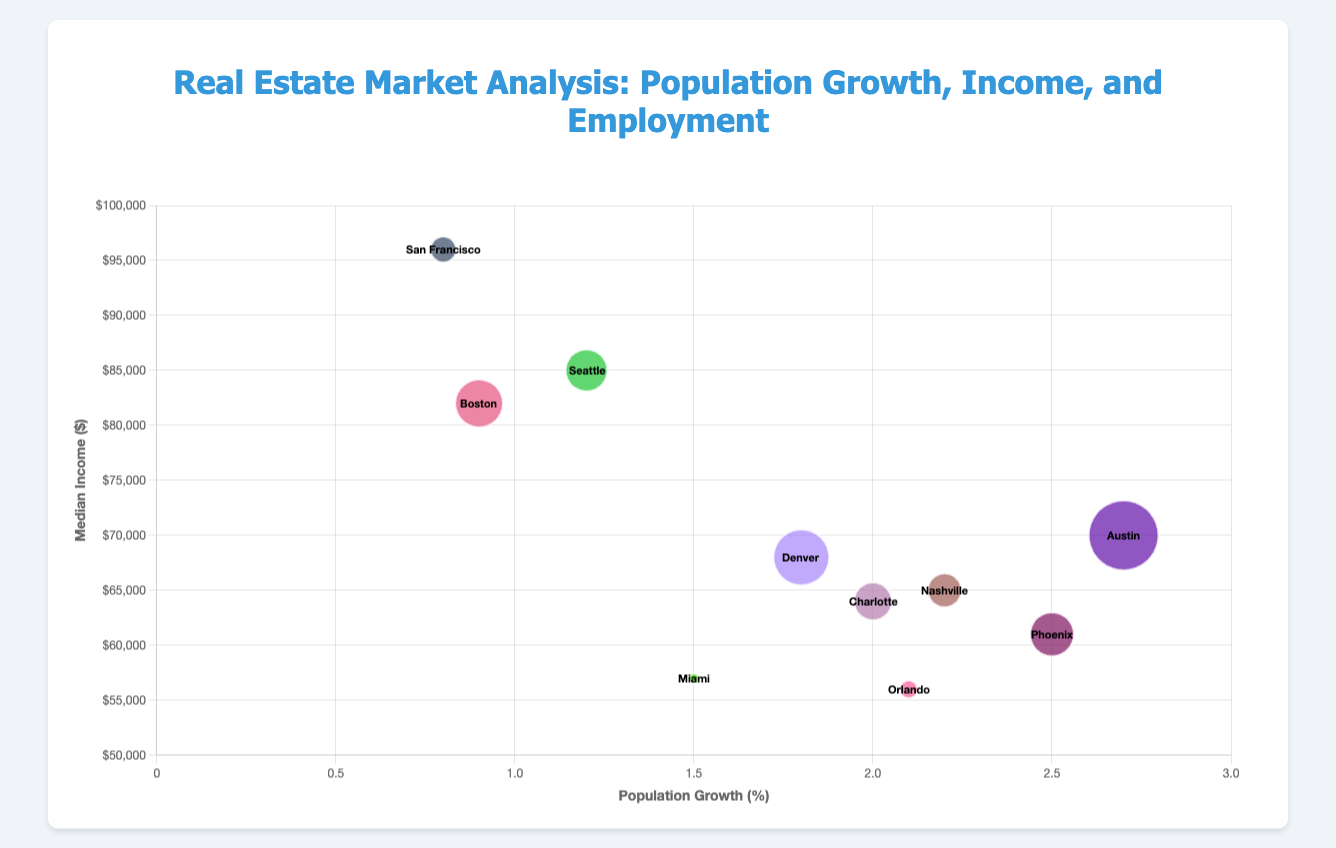What's the title of the figure? The title of the figure is displayed at the top and reads "Real Estate Market Analysis: Population Growth, Income, and Employment"
Answer: Real Estate Market Analysis: Population Growth, Income, and Employment Which city has the highest Population Growth Percentage? To find the highest Population Growth Percentage, look at the x-axis values and identify the bubble that is most to the right. Austin has the highest Population Growth Percentage of 2.7%
Answer: Austin What's the approximate median income for the City with the highest employment rate? First, locate the city with the highest employment rate by noticing the largest bubble size. Austin has the highest employment rate at 96.5% and its median income is $70,000
Answer: $70,000 How many cities have a median income below $60,000? Locate all the bubbles below the $60,000 mark along the y-axis. Miami ($57,000) and Orlando ($56,000) are the two cities with a median income below $60,000.
Answer: 2 Which city has the smallest bubble? The size of the bubble corresponds to the employment rate minus 93, multiplied by 10. San Francisco appears to have the smallest bubble.
Answer: San Francisco Among the cities with a population growth percentage above 2.0%, which one has the lowest median income? Identify cities with a Population Growth Percentage above 2.0%: Austin (2.7%), Nashville (2.2%), Charlotte (2.0%), Orlando (2.1%), and Phoenix (2.5%). Among these, Orlando has the lowest median income of $56,000
Answer: Orlando What's the average employment rate of cities with a median income above $80,000? Identify cities with a median income above $80,000: Seattle, San Francisco, and Boston. Their employment rates are 95.1%, 94.3%, and 95.4% respectively. Average is (95.1 + 94.3 + 95.4) / 3 = 94.93%.
Answer: 94.93% Which city has a median income closest to $60,000? Identify cities with median incomes closest to $60,000 by looking at the y-axis and finding the nearest value: Phoenix with a median income of $61,000 is the closest.
Answer: Phoenix Compare the population growth and median income of Austin and Denver. Which one has a higher population growth percentage and which one has a higher median income? Austin has a population growth percentage of 2.7% and a median income of $70,000. Denver has a population growth percentage of 1.8% and a median income of $68,000. Austin has a higher population growth percentage, and Austin also has a higher median income.
Answer: Austin; Austin Which city has an employment rate lower than 94%? Identify cities with a bubble size smaller than (95 - 93) * 10 = 20 on the chart. San Francisco (94.3%) and Miami (93.5%) have an employment rate lower than 94%.
Answer: Miami 